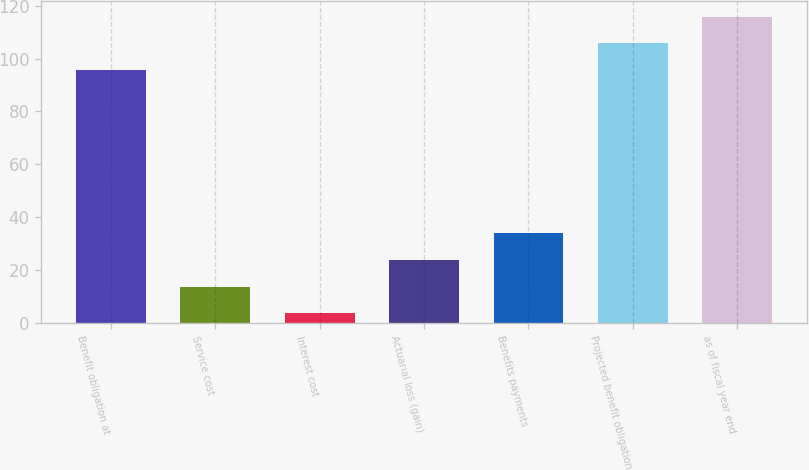<chart> <loc_0><loc_0><loc_500><loc_500><bar_chart><fcel>Benefit obligation at<fcel>Service cost<fcel>Interest cost<fcel>Actuarial loss (gain)<fcel>Benefits payments<fcel>Projected benefit obligation<fcel>as of fiscal year end<nl><fcel>95.7<fcel>13.79<fcel>3.7<fcel>23.88<fcel>33.97<fcel>105.79<fcel>115.88<nl></chart> 